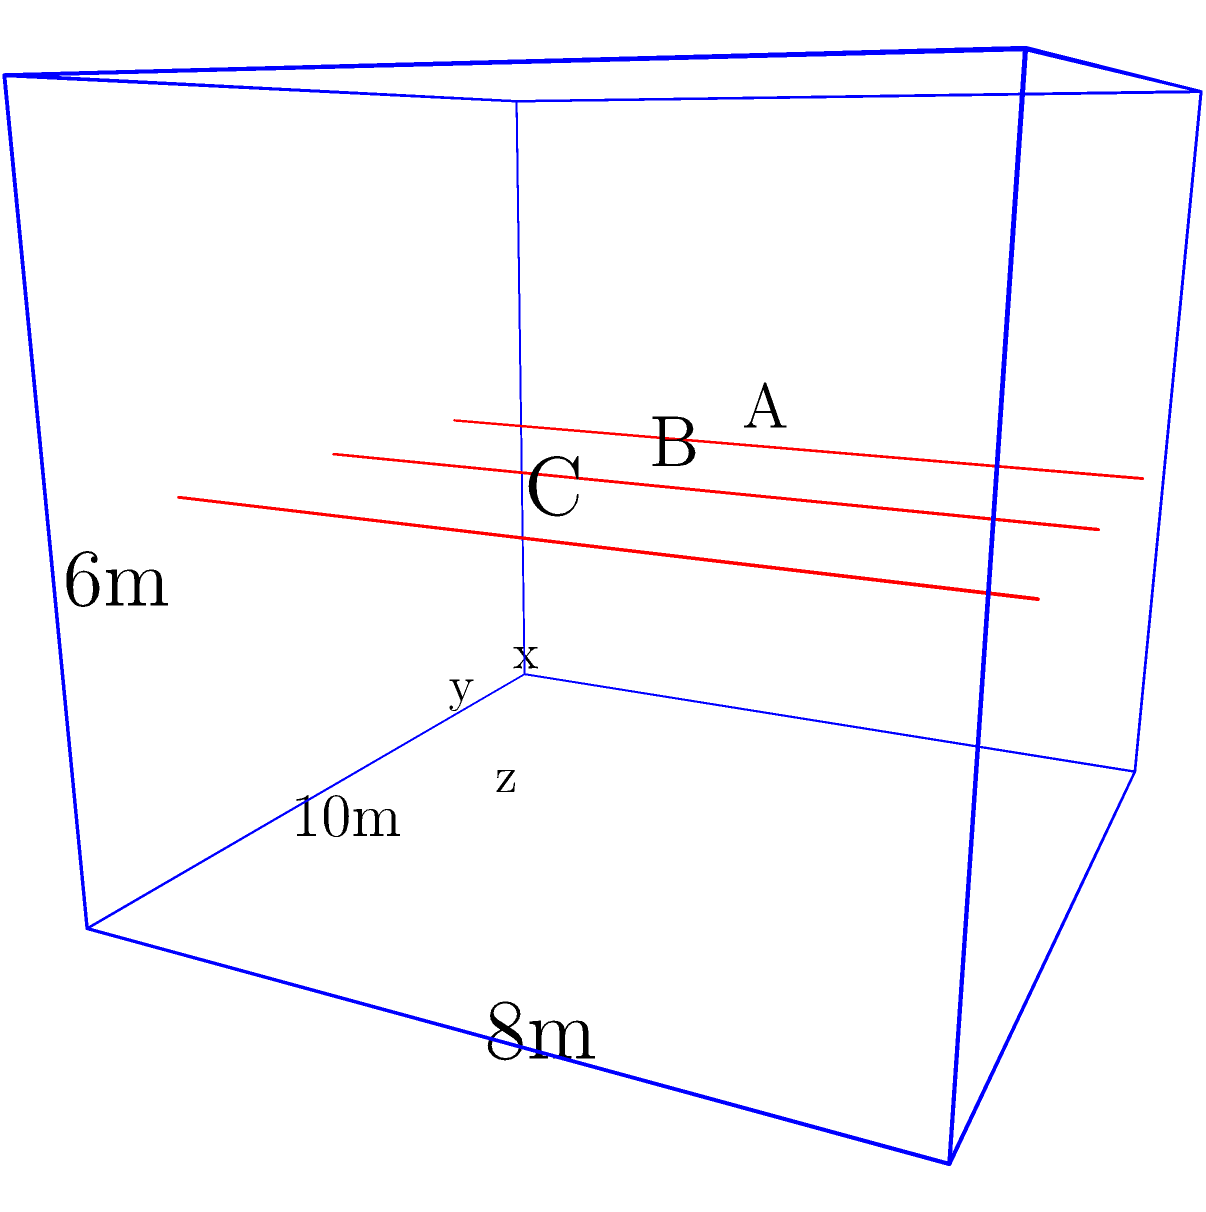You are designing the support structure for a rectangular building with dimensions 10m x 8m x 6m (length x width x height). Three vertical support beams (A, B, and C) need to be placed along the length of the building at a height of 3m. Beam A is placed at x = 2m, and beam C is placed at x = 8m. If the optimal placement requires the distance between each beam to be equal, at what x-coordinate should beam B be placed? To solve this problem, we'll follow these steps:

1) First, let's understand the given information:
   - The building is 10m long (x-axis)
   - Beam A is at x = 2m
   - Beam C is at x = 8m
   - The distance between each beam should be equal

2) Let's calculate the total distance between beam A and beam C:
   $$ 8m - 2m = 6m $$

3) Since we need two equal segments (A to B, and B to C), we divide this distance by 2:
   $$ 6m \div 2 = 3m $$

4) So, beam B should be placed 3m from beam A. We can calculate its x-coordinate:
   $$ x_{B} = x_{A} + 3m = 2m + 3m = 5m $$

5) We can verify this is correct by checking the distance from B to C:
   $$ x_{C} - x_{B} = 8m - 5m = 3m $$

Therefore, beam B should be placed at x = 5m to ensure equal distances between the beams.
Answer: 5m 